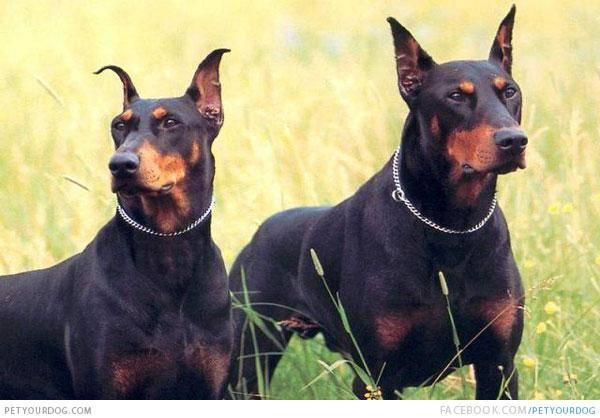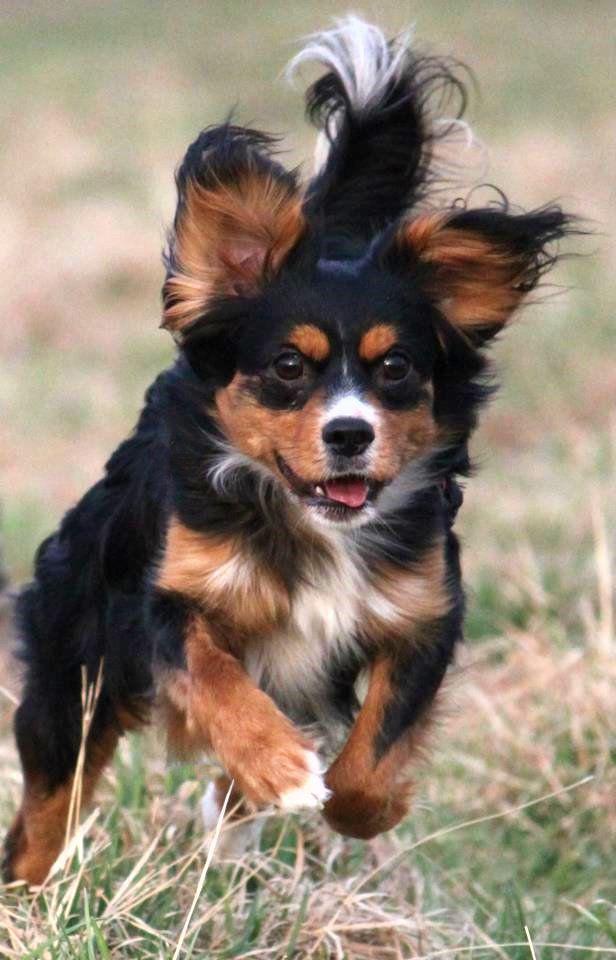The first image is the image on the left, the second image is the image on the right. Evaluate the accuracy of this statement regarding the images: "There are three dogs in total.". Is it true? Answer yes or no. Yes. The first image is the image on the left, the second image is the image on the right. Evaluate the accuracy of this statement regarding the images: "There are three dogs.". Is it true? Answer yes or no. Yes. 